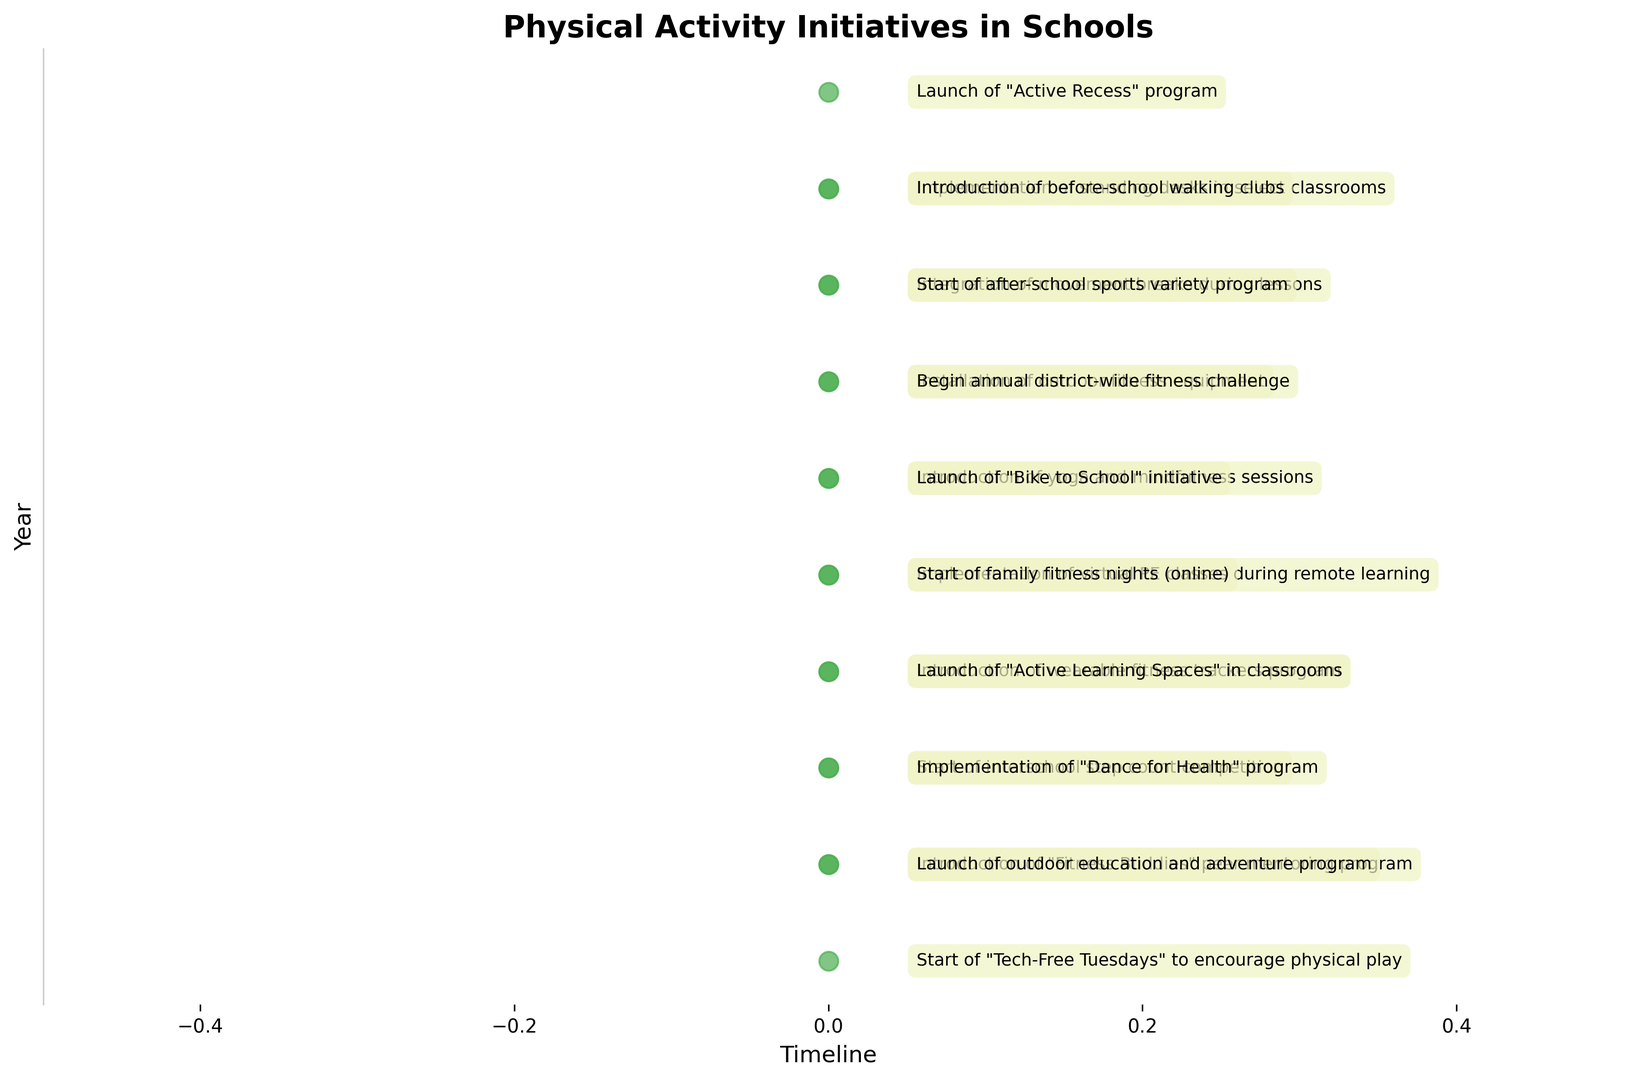What is the first initiative introduced in the timeline? To find the first initiative, locate the earliest year on the y-axis. The event listed for 2015 is the "Launch of 'Active Recess' program".
Answer: Launch of "Active Recess" program How many initiatives were introduced in the year 2016? Look at the y-axis for the year 2016, and count the number of events listed. There are two events: "Implementation of standing desks in select classrooms" and "Introduction of before-school walking clubs".
Answer: 2 Which year had the highest number of new initiatives introduced? Count the number of events for each year by looking at the y-axis labels. The year with the most events (2 each) is 2016, 2017, 2018, 2019, 2020, 2021, and 2022.
Answer: 2016, 2017, 2018, 2019, 2020, 2021, 2022 What type of initiative was introduced in 2023 that involves mentoring? Identify the event for the year 2023 and look for keywords related to mentoring. The "Introduction of 'Fitness Buddies' peer mentoring program" fits this description.
Answer: Fitness Buddies peer mentoring program Identify and describe any initiative related to mindfulness. Look through the events for keywords related to mindfulness and find the year. In 2019, "Introduction of yoga and mindfulness sessions" was noted.
Answer: Introduction of yoga and mindfulness sessions (2019) Compare the initiatives introduced in 2020. Which one was specifically adapted for remote learning? Examine the initiatives for 2020; the given are "Implementation of virtual PE classes during remote learning" and "Start of family fitness nights (online)". Both seem adapted for remote learning, with the former being explicitly stated.
Answer: Implementation of virtual PE classes during remote learning Calculate the average number of initiatives introduced over the years when new initiatives were introduced. Sum the total number of initiatives (17) and divide this by the number of years with new initiatives (10). 17 initiatives/10 years = 1.7 initiatives per year.
Answer: 1.7 Which initiative aims to discourage the use of technology to encourage physical activity, and in what year was it introduced? Look for keywords related to discouraging technology. In 2024, the initiative "Start of 'Tech-Free Tuesdays' to encourage physical play" was introduced.
Answer: Tech-Free Tuesdays (2024) What new initiative was launched in the schools in 2018 that involves an outdoor activity? Identify the events for 2018 and look for any outdoor-related activities. The "Installation of outdoor fitness equipment" fits this description.
Answer: Installation of outdoor fitness equipment Compare the years 2017 and 2019. Which year had more initiatives introduced and by how many? Count the initiatives introduced in each year. In 2017, there are 2 initiatives. In 2019, there are also 2 initiatives. Since both years have the same number, the difference is zero.
Answer: 0 